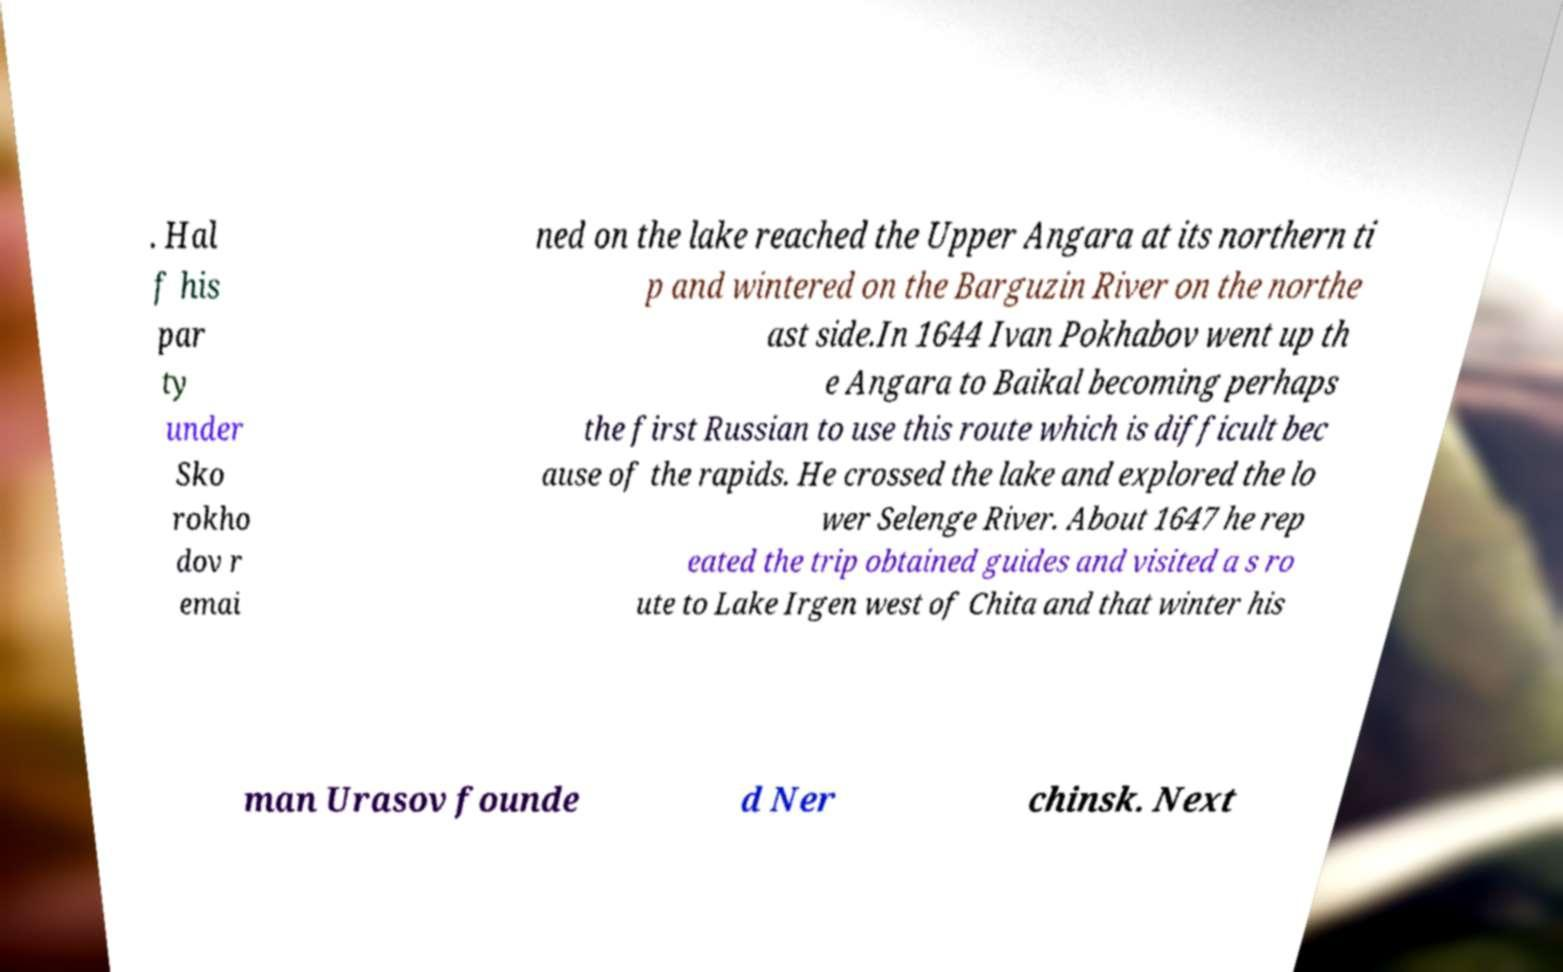What messages or text are displayed in this image? I need them in a readable, typed format. . Hal f his par ty under Sko rokho dov r emai ned on the lake reached the Upper Angara at its northern ti p and wintered on the Barguzin River on the northe ast side.In 1644 Ivan Pokhabov went up th e Angara to Baikal becoming perhaps the first Russian to use this route which is difficult bec ause of the rapids. He crossed the lake and explored the lo wer Selenge River. About 1647 he rep eated the trip obtained guides and visited a s ro ute to Lake Irgen west of Chita and that winter his man Urasov founde d Ner chinsk. Next 